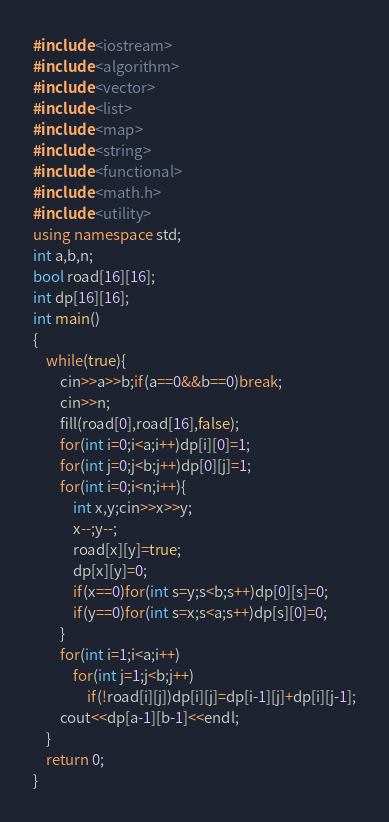Convert code to text. <code><loc_0><loc_0><loc_500><loc_500><_C++_>#include <iostream>
#include <algorithm>
#include <vector>
#include <list>
#include <map>
#include <string>
#include <functional>
#include <math.h>
#include <utility>
using namespace std;
int a,b,n;
bool road[16][16];
int dp[16][16];
int main()
{
	while(true){
		cin>>a>>b;if(a==0&&b==0)break;
		cin>>n;
		fill(road[0],road[16],false);
		for(int i=0;i<a;i++)dp[i][0]=1;
		for(int j=0;j<b;j++)dp[0][j]=1;
		for(int i=0;i<n;i++){
			int x,y;cin>>x>>y;
			x--;y--;
			road[x][y]=true;
			dp[x][y]=0;
			if(x==0)for(int s=y;s<b;s++)dp[0][s]=0;
			if(y==0)for(int s=x;s<a;s++)dp[s][0]=0;
		}
		for(int i=1;i<a;i++)
			for(int j=1;j<b;j++)
				if(!road[i][j])dp[i][j]=dp[i-1][j]+dp[i][j-1];
		cout<<dp[a-1][b-1]<<endl;
	}
	return 0;
}</code> 